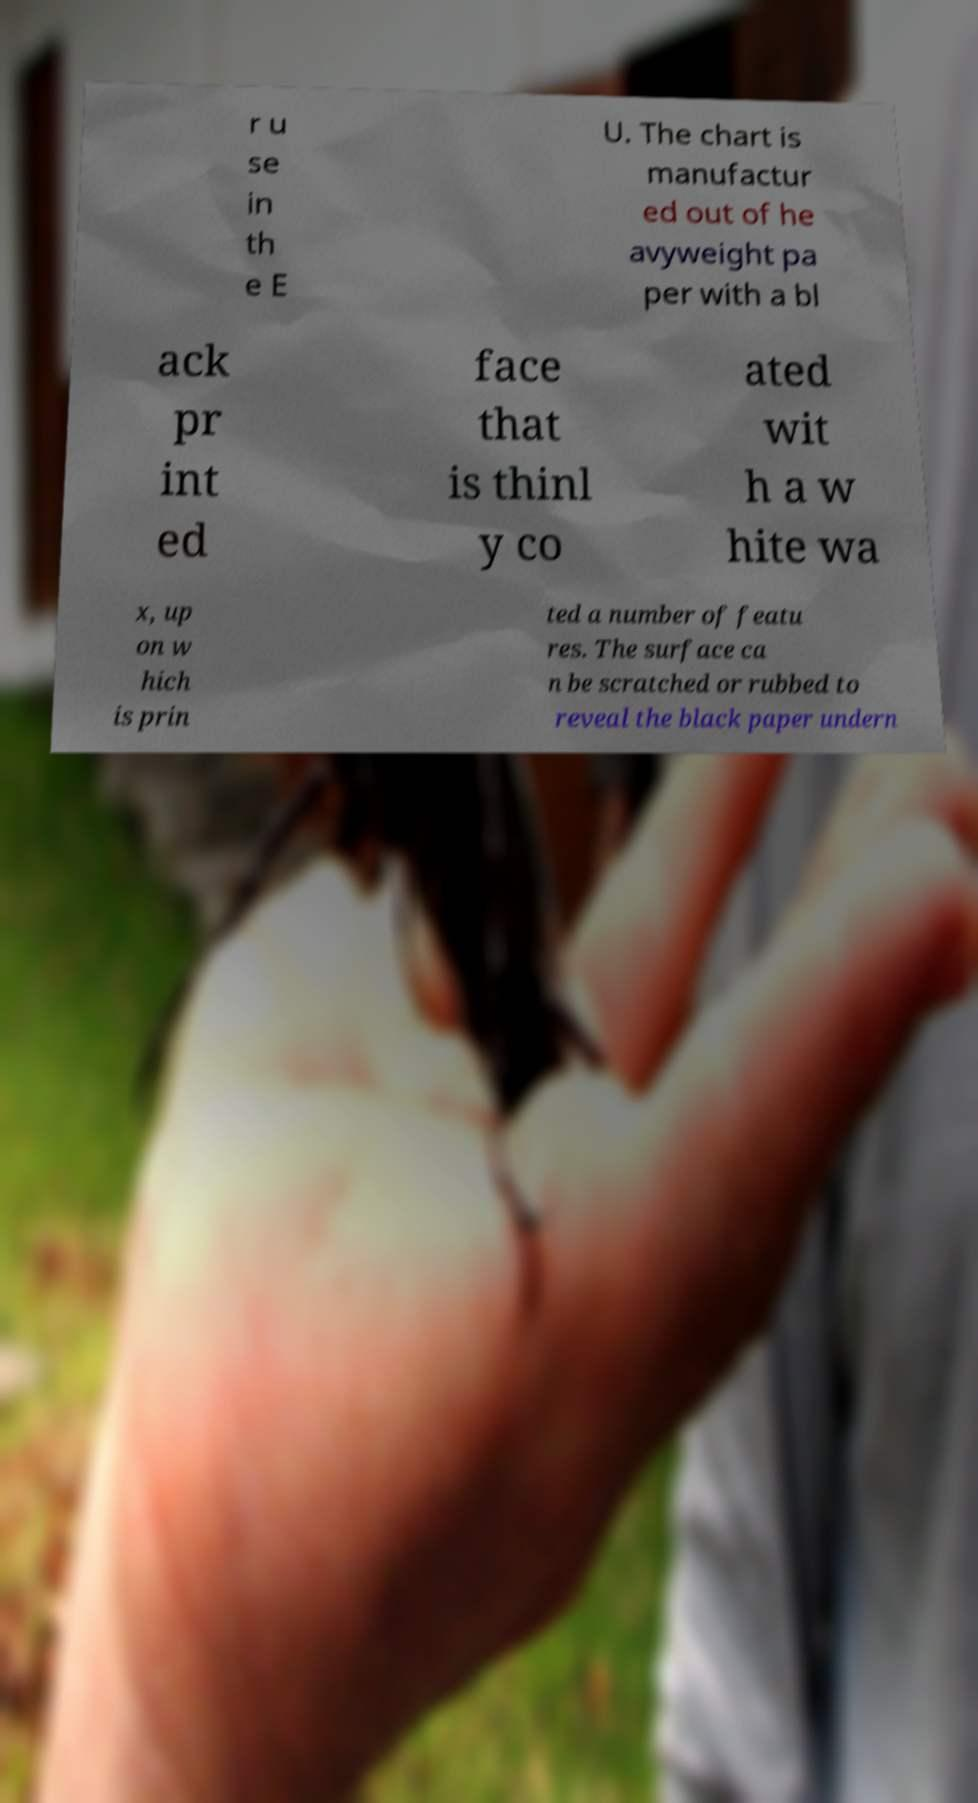Please identify and transcribe the text found in this image. r u se in th e E U. The chart is manufactur ed out of he avyweight pa per with a bl ack pr int ed face that is thinl y co ated wit h a w hite wa x, up on w hich is prin ted a number of featu res. The surface ca n be scratched or rubbed to reveal the black paper undern 